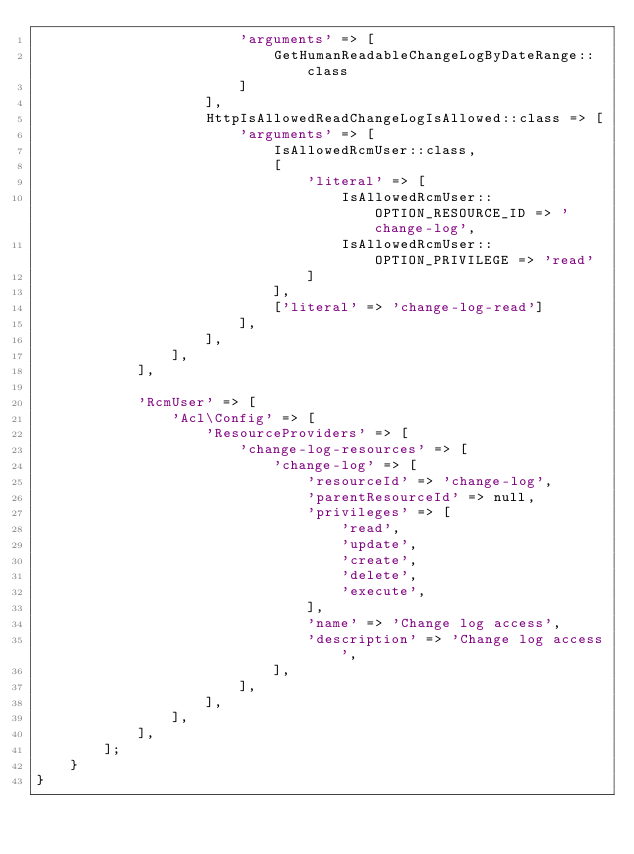Convert code to text. <code><loc_0><loc_0><loc_500><loc_500><_PHP_>                        'arguments' => [
                            GetHumanReadableChangeLogByDateRange::class
                        ]
                    ],
                    HttpIsAllowedReadChangeLogIsAllowed::class => [
                        'arguments' => [
                            IsAllowedRcmUser::class,
                            [
                                'literal' => [
                                    IsAllowedRcmUser::OPTION_RESOURCE_ID => 'change-log',
                                    IsAllowedRcmUser::OPTION_PRIVILEGE => 'read'
                                ]
                            ],
                            ['literal' => 'change-log-read']
                        ],
                    ],
                ],
            ],

            'RcmUser' => [
                'Acl\Config' => [
                    'ResourceProviders' => [
                        'change-log-resources' => [
                            'change-log' => [
                                'resourceId' => 'change-log',
                                'parentResourceId' => null,
                                'privileges' => [
                                    'read',
                                    'update',
                                    'create',
                                    'delete',
                                    'execute',
                                ],
                                'name' => 'Change log access',
                                'description' => 'Change log access',
                            ],
                        ],
                    ],
                ],
            ],
        ];
    }
}
</code> 